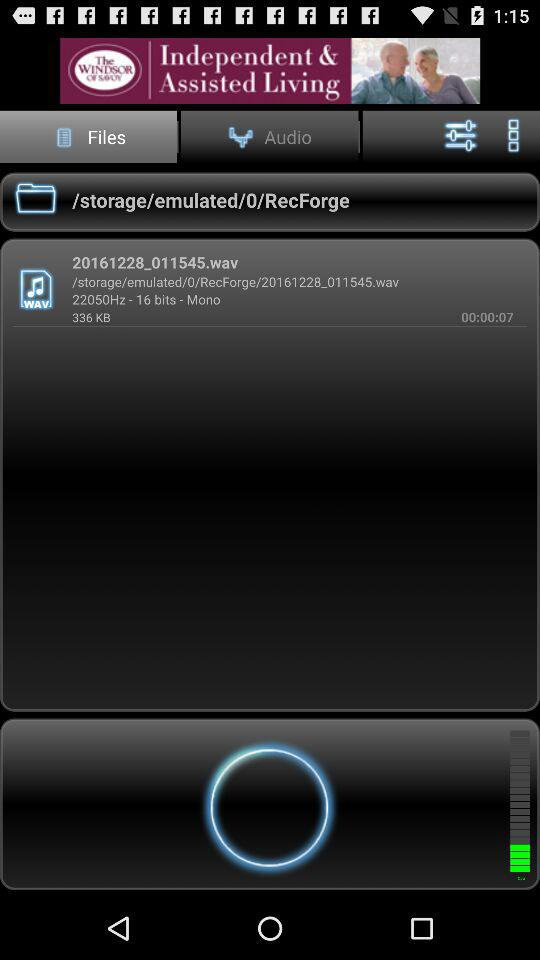What's the duration of the audio file? The duration is 7 seconds. 